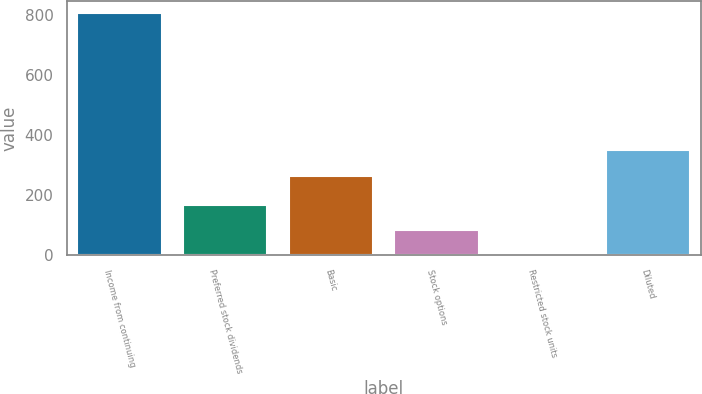Convert chart to OTSL. <chart><loc_0><loc_0><loc_500><loc_500><bar_chart><fcel>Income from continuing<fcel>Preferred stock dividends<fcel>Basic<fcel>Stock options<fcel>Restricted stock units<fcel>Diluted<nl><fcel>807.1<fcel>168.34<fcel>265.4<fcel>84.37<fcel>0.4<fcel>349.37<nl></chart> 